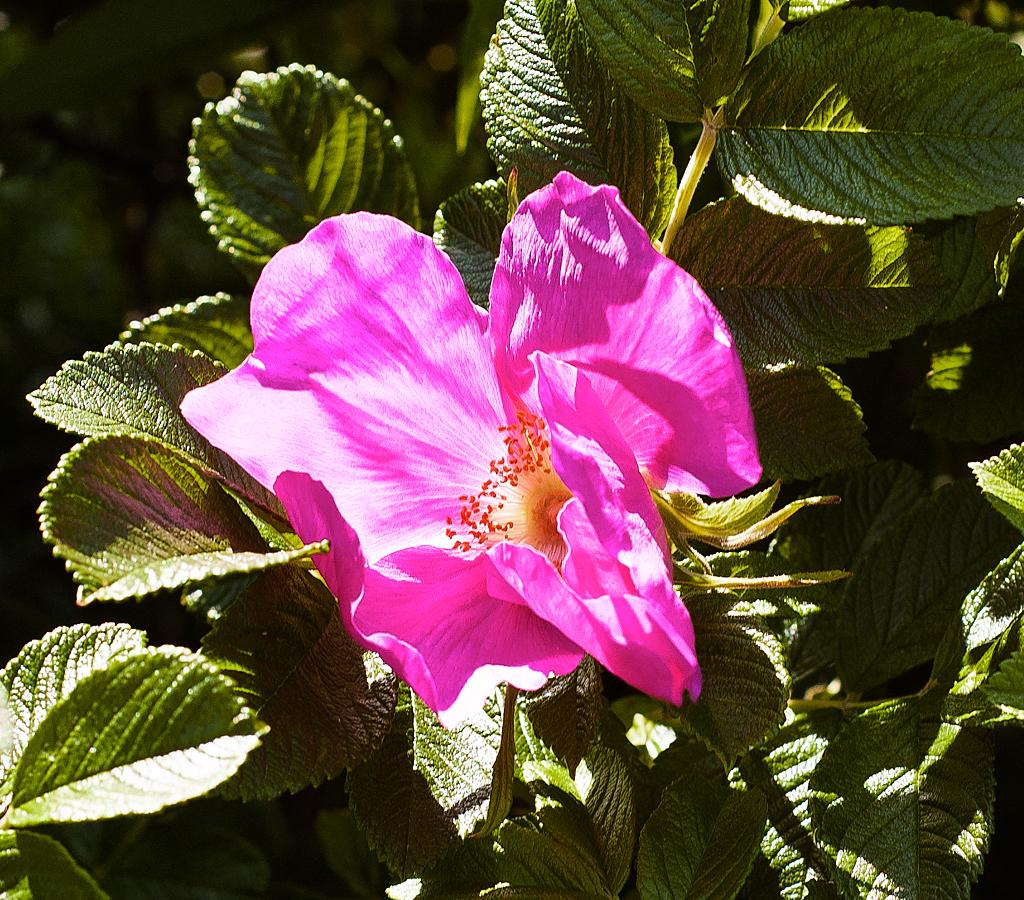What is the main subject of the image? There is a flower in the center of the image. What color is the flower? The flower is pink in color. What else can be seen around the flower in the image? There are leaves around the area of the image. What advice does the doctor give to the patient in the image? There is no doctor or patient present in the image; it features a pink flower surrounded by leaves. 